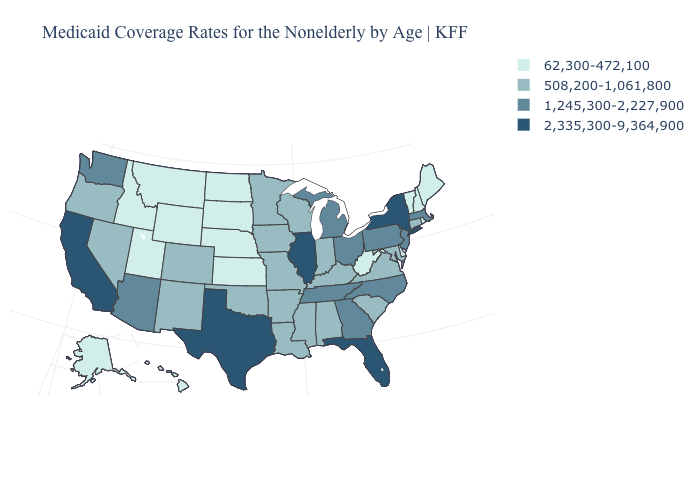Does Florida have the highest value in the South?
Be succinct. Yes. What is the value of Hawaii?
Quick response, please. 62,300-472,100. What is the highest value in the South ?
Concise answer only. 2,335,300-9,364,900. What is the value of South Carolina?
Give a very brief answer. 508,200-1,061,800. Among the states that border North Carolina , does Georgia have the lowest value?
Keep it brief. No. What is the lowest value in the South?
Be succinct. 62,300-472,100. What is the value of Massachusetts?
Answer briefly. 1,245,300-2,227,900. Name the states that have a value in the range 2,335,300-9,364,900?
Keep it brief. California, Florida, Illinois, New York, Texas. Name the states that have a value in the range 508,200-1,061,800?
Give a very brief answer. Alabama, Arkansas, Colorado, Connecticut, Indiana, Iowa, Kentucky, Louisiana, Maryland, Minnesota, Mississippi, Missouri, Nevada, New Mexico, Oklahoma, Oregon, South Carolina, Virginia, Wisconsin. Does the map have missing data?
Give a very brief answer. No. Does the first symbol in the legend represent the smallest category?
Concise answer only. Yes. Name the states that have a value in the range 508,200-1,061,800?
Be succinct. Alabama, Arkansas, Colorado, Connecticut, Indiana, Iowa, Kentucky, Louisiana, Maryland, Minnesota, Mississippi, Missouri, Nevada, New Mexico, Oklahoma, Oregon, South Carolina, Virginia, Wisconsin. Among the states that border Iowa , does South Dakota have the lowest value?
Keep it brief. Yes. What is the value of Minnesota?
Answer briefly. 508,200-1,061,800. Name the states that have a value in the range 508,200-1,061,800?
Concise answer only. Alabama, Arkansas, Colorado, Connecticut, Indiana, Iowa, Kentucky, Louisiana, Maryland, Minnesota, Mississippi, Missouri, Nevada, New Mexico, Oklahoma, Oregon, South Carolina, Virginia, Wisconsin. 